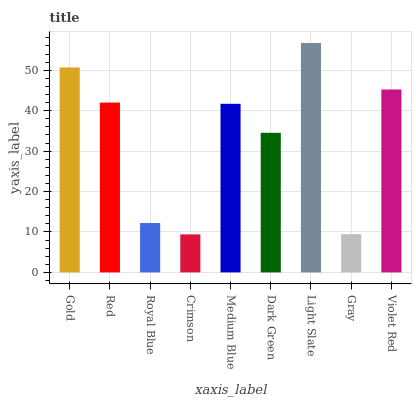Is Crimson the minimum?
Answer yes or no. Yes. Is Light Slate the maximum?
Answer yes or no. Yes. Is Red the minimum?
Answer yes or no. No. Is Red the maximum?
Answer yes or no. No. Is Gold greater than Red?
Answer yes or no. Yes. Is Red less than Gold?
Answer yes or no. Yes. Is Red greater than Gold?
Answer yes or no. No. Is Gold less than Red?
Answer yes or no. No. Is Medium Blue the high median?
Answer yes or no. Yes. Is Medium Blue the low median?
Answer yes or no. Yes. Is Light Slate the high median?
Answer yes or no. No. Is Dark Green the low median?
Answer yes or no. No. 